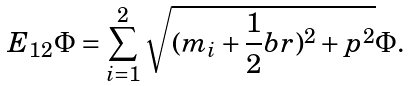<formula> <loc_0><loc_0><loc_500><loc_500>E _ { 1 2 } \Phi = \sum _ { i = 1 } ^ { 2 } \sqrt { ( m _ { i } + \frac { 1 } { 2 } b r ) ^ { 2 } + \boldmath p ^ { 2 } } \Phi .</formula> 